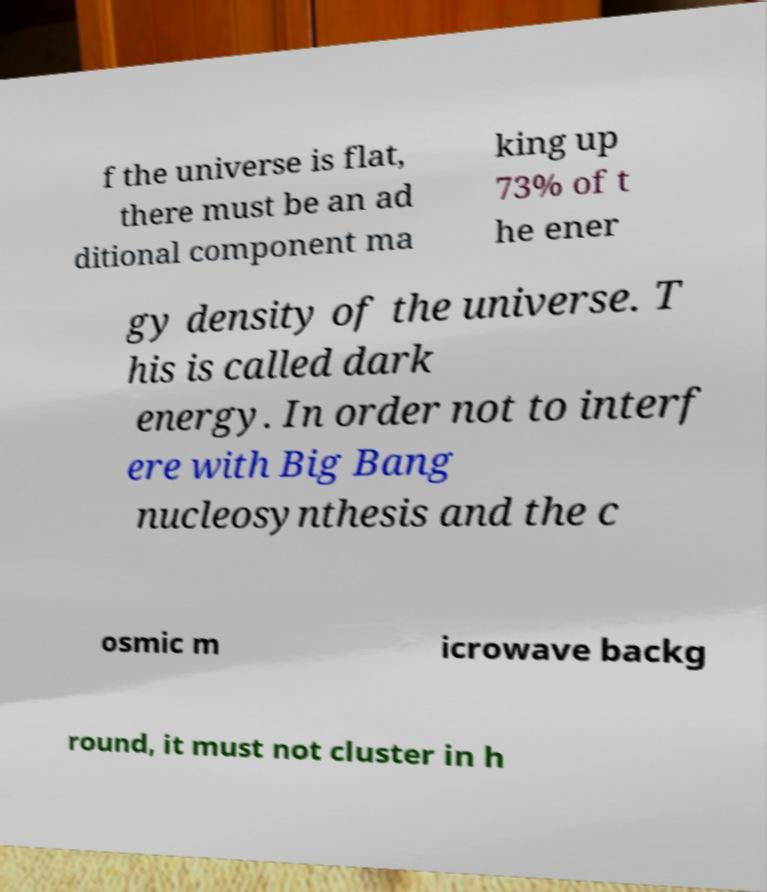I need the written content from this picture converted into text. Can you do that? f the universe is flat, there must be an ad ditional component ma king up 73% of t he ener gy density of the universe. T his is called dark energy. In order not to interf ere with Big Bang nucleosynthesis and the c osmic m icrowave backg round, it must not cluster in h 